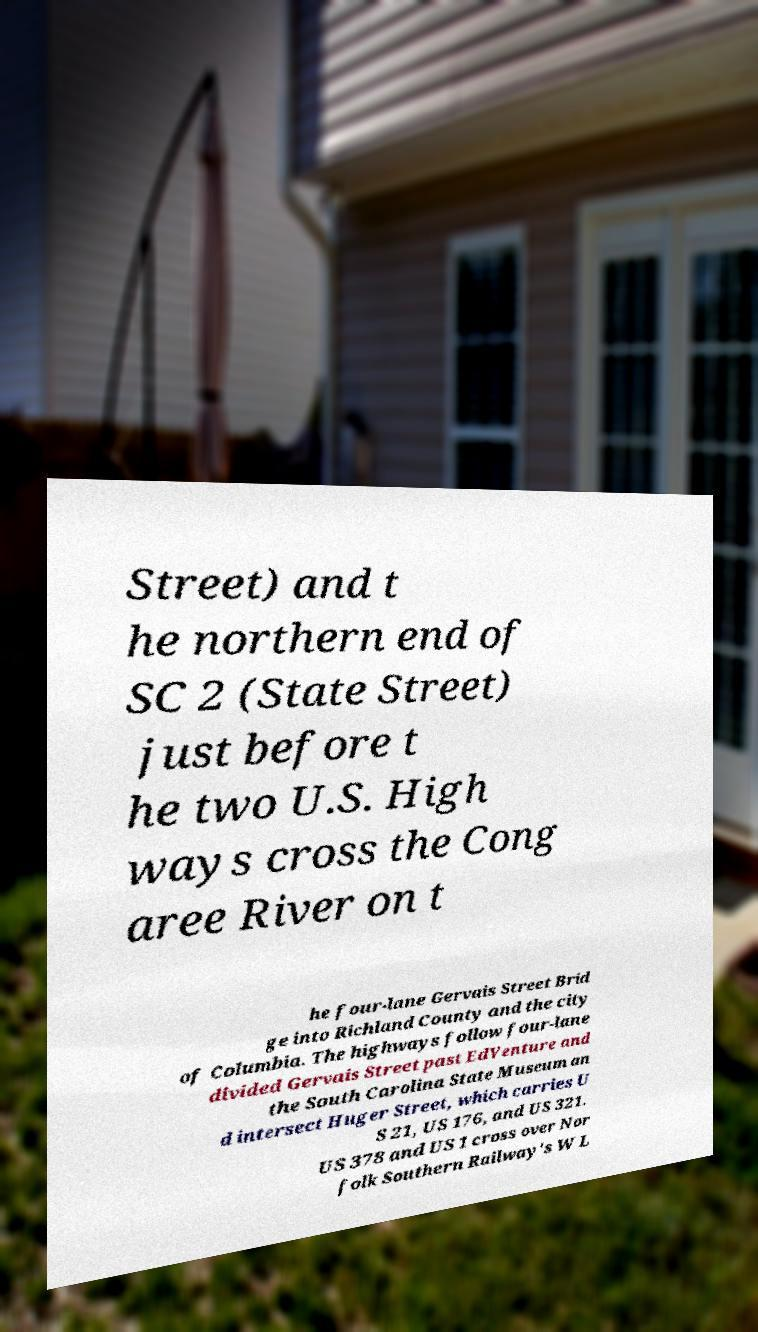Can you read and provide the text displayed in the image?This photo seems to have some interesting text. Can you extract and type it out for me? Street) and t he northern end of SC 2 (State Street) just before t he two U.S. High ways cross the Cong aree River on t he four-lane Gervais Street Brid ge into Richland County and the city of Columbia. The highways follow four-lane divided Gervais Street past EdVenture and the South Carolina State Museum an d intersect Huger Street, which carries U S 21, US 176, and US 321. US 378 and US 1 cross over Nor folk Southern Railway's W L 